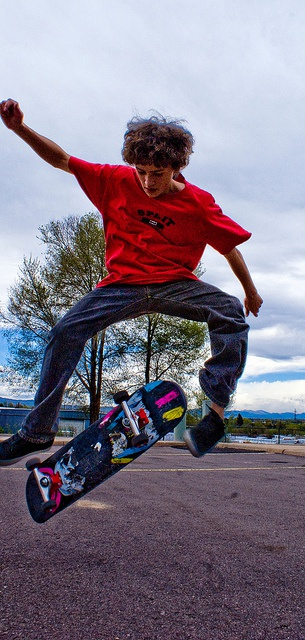Describe the objects in this image and their specific colors. I can see people in lavender, black, and maroon tones and skateboard in lavender, black, navy, gray, and blue tones in this image. 